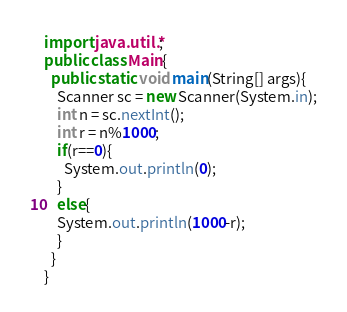Convert code to text. <code><loc_0><loc_0><loc_500><loc_500><_Java_>import java.util.*;
public class Main{
  public static void main(String[] args){
    Scanner sc = new Scanner(System.in);
    int n = sc.nextInt();
    int r = n%1000;
    if(r==0){
      System.out.println(0);
    }
    else{
    System.out.println(1000-r);
    }
  }
}</code> 